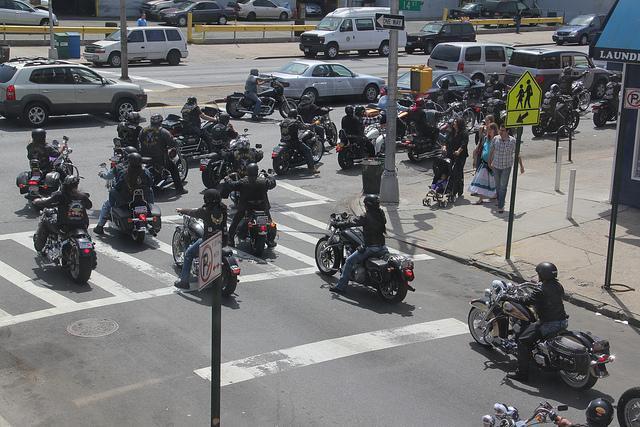How many trucks can be seen?
Give a very brief answer. 4. How many people can you see?
Give a very brief answer. 3. How many motorcycles are there?
Give a very brief answer. 4. How many cars are in the photo?
Give a very brief answer. 5. How many cows in the picture?
Give a very brief answer. 0. 